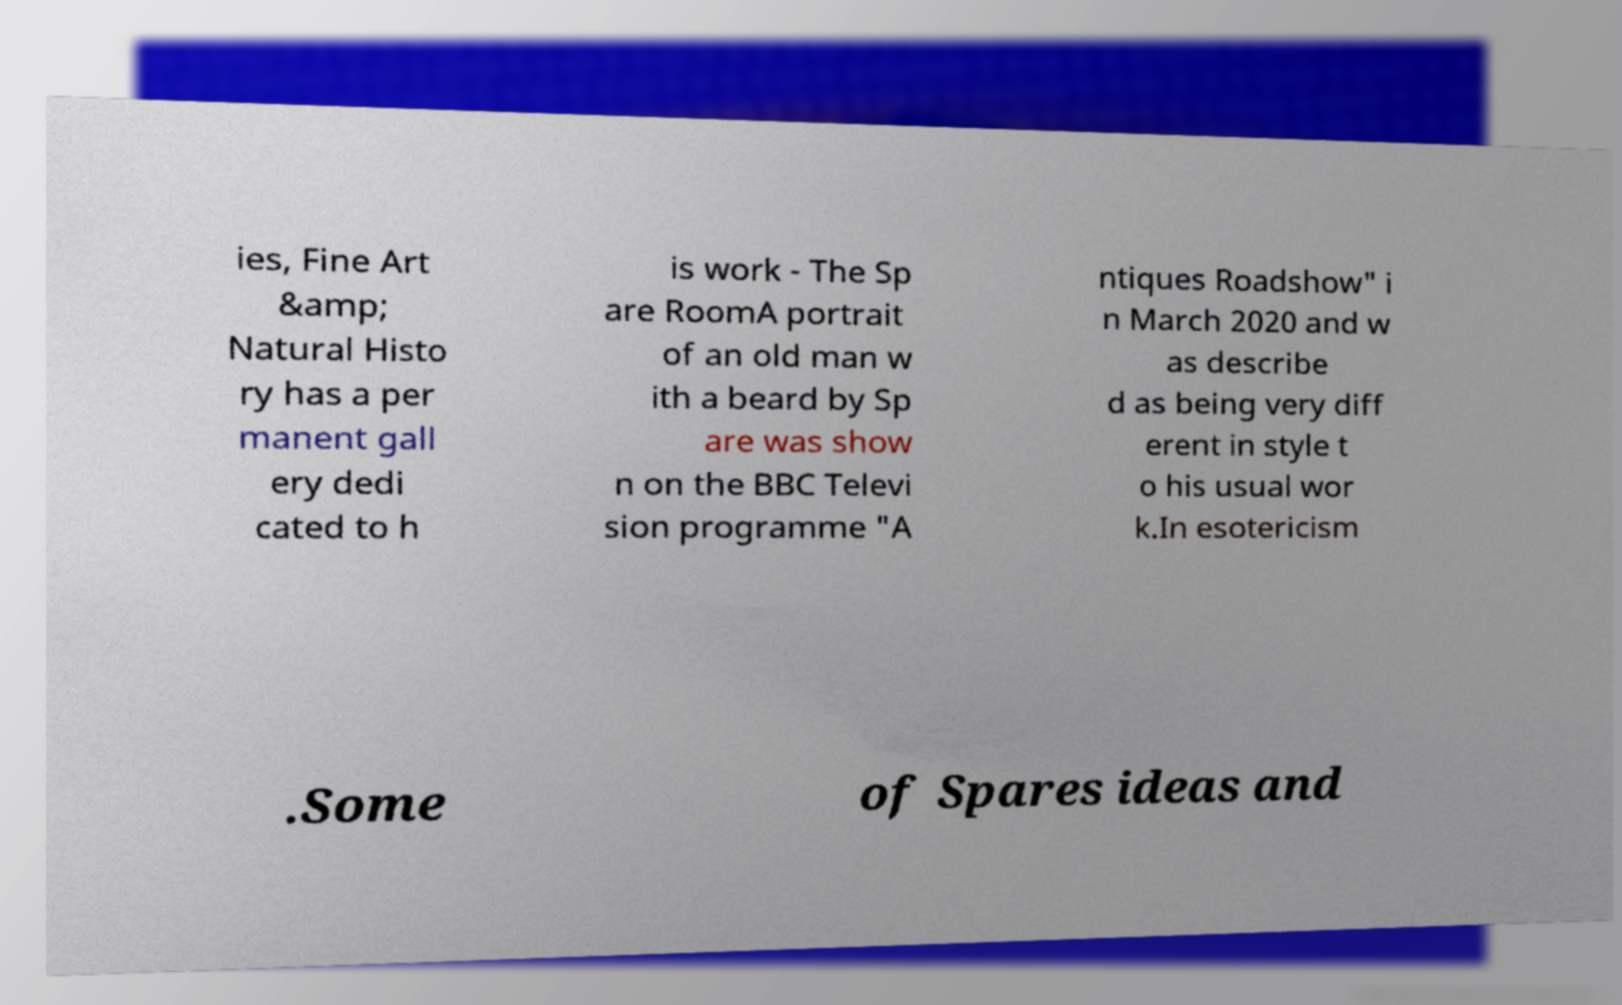For documentation purposes, I need the text within this image transcribed. Could you provide that? ies, Fine Art &amp; Natural Histo ry has a per manent gall ery dedi cated to h is work - The Sp are RoomA portrait of an old man w ith a beard by Sp are was show n on the BBC Televi sion programme "A ntiques Roadshow" i n March 2020 and w as describe d as being very diff erent in style t o his usual wor k.In esotericism .Some of Spares ideas and 